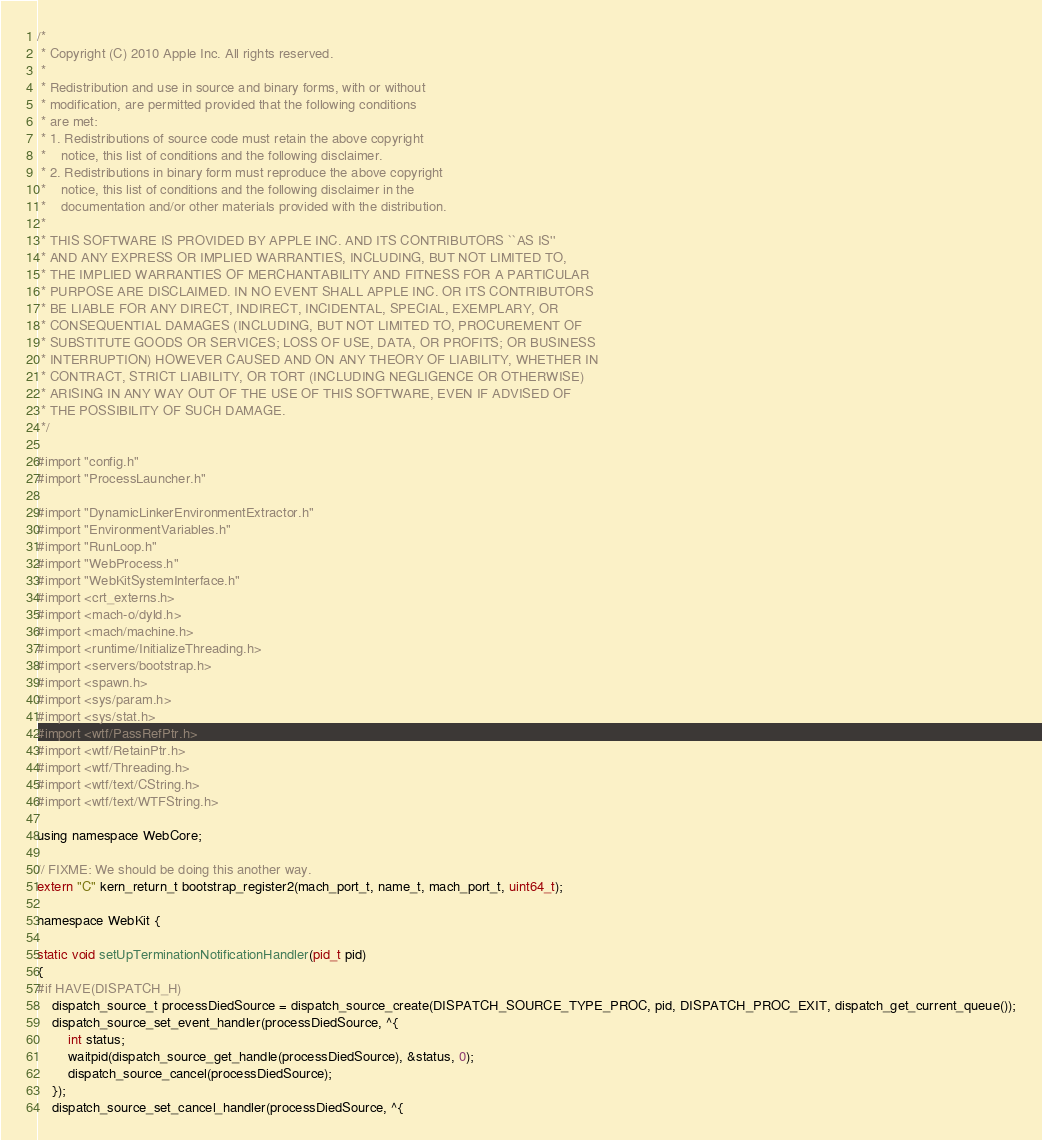Convert code to text. <code><loc_0><loc_0><loc_500><loc_500><_ObjectiveC_>/*
 * Copyright (C) 2010 Apple Inc. All rights reserved.
 *
 * Redistribution and use in source and binary forms, with or without
 * modification, are permitted provided that the following conditions
 * are met:
 * 1. Redistributions of source code must retain the above copyright
 *    notice, this list of conditions and the following disclaimer.
 * 2. Redistributions in binary form must reproduce the above copyright
 *    notice, this list of conditions and the following disclaimer in the
 *    documentation and/or other materials provided with the distribution.
 *
 * THIS SOFTWARE IS PROVIDED BY APPLE INC. AND ITS CONTRIBUTORS ``AS IS''
 * AND ANY EXPRESS OR IMPLIED WARRANTIES, INCLUDING, BUT NOT LIMITED TO,
 * THE IMPLIED WARRANTIES OF MERCHANTABILITY AND FITNESS FOR A PARTICULAR
 * PURPOSE ARE DISCLAIMED. IN NO EVENT SHALL APPLE INC. OR ITS CONTRIBUTORS
 * BE LIABLE FOR ANY DIRECT, INDIRECT, INCIDENTAL, SPECIAL, EXEMPLARY, OR
 * CONSEQUENTIAL DAMAGES (INCLUDING, BUT NOT LIMITED TO, PROCUREMENT OF
 * SUBSTITUTE GOODS OR SERVICES; LOSS OF USE, DATA, OR PROFITS; OR BUSINESS
 * INTERRUPTION) HOWEVER CAUSED AND ON ANY THEORY OF LIABILITY, WHETHER IN
 * CONTRACT, STRICT LIABILITY, OR TORT (INCLUDING NEGLIGENCE OR OTHERWISE)
 * ARISING IN ANY WAY OUT OF THE USE OF THIS SOFTWARE, EVEN IF ADVISED OF
 * THE POSSIBILITY OF SUCH DAMAGE.
 */

#import "config.h"
#import "ProcessLauncher.h"

#import "DynamicLinkerEnvironmentExtractor.h"
#import "EnvironmentVariables.h"
#import "RunLoop.h"
#import "WebProcess.h"
#import "WebKitSystemInterface.h"
#import <crt_externs.h>
#import <mach-o/dyld.h>
#import <mach/machine.h>
#import <runtime/InitializeThreading.h>
#import <servers/bootstrap.h>
#import <spawn.h>
#import <sys/param.h>
#import <sys/stat.h>
#import <wtf/PassRefPtr.h>
#import <wtf/RetainPtr.h>
#import <wtf/Threading.h>
#import <wtf/text/CString.h>
#import <wtf/text/WTFString.h>

using namespace WebCore;

// FIXME: We should be doing this another way.
extern "C" kern_return_t bootstrap_register2(mach_port_t, name_t, mach_port_t, uint64_t);

namespace WebKit {

static void setUpTerminationNotificationHandler(pid_t pid)
{
#if HAVE(DISPATCH_H)
    dispatch_source_t processDiedSource = dispatch_source_create(DISPATCH_SOURCE_TYPE_PROC, pid, DISPATCH_PROC_EXIT, dispatch_get_current_queue());
    dispatch_source_set_event_handler(processDiedSource, ^{
        int status;
        waitpid(dispatch_source_get_handle(processDiedSource), &status, 0);
        dispatch_source_cancel(processDiedSource);
    });
    dispatch_source_set_cancel_handler(processDiedSource, ^{</code> 